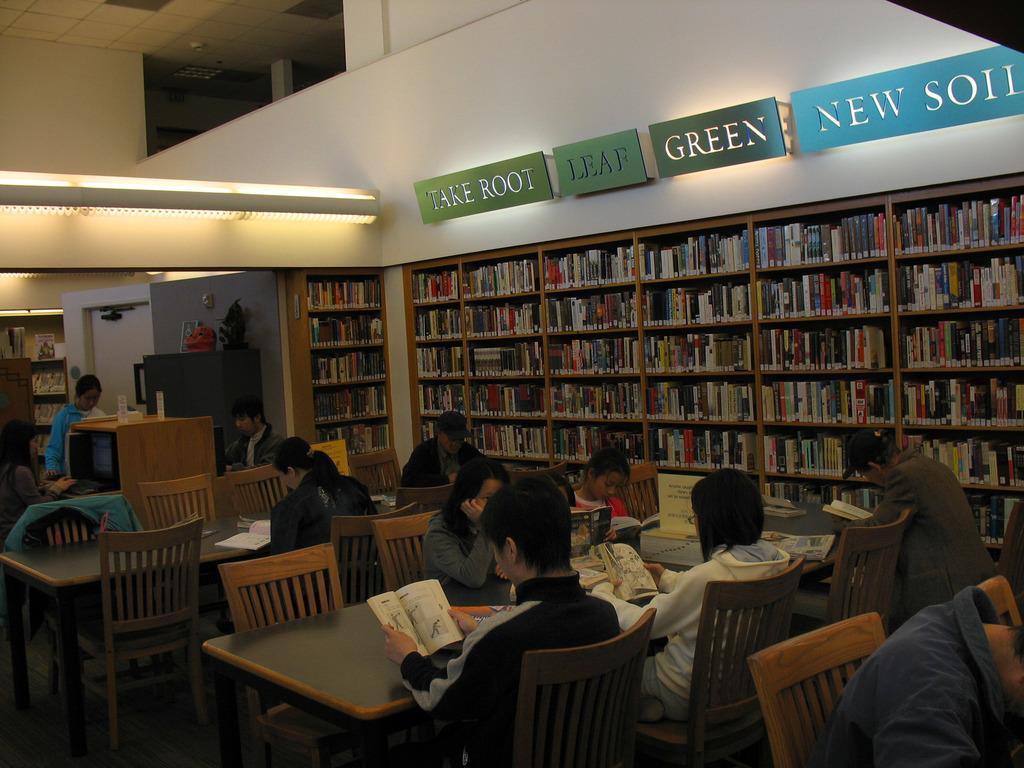In one or two sentences, can you explain what this image depicts? In this image there are group of people sitting in chair , and in the back ground there are name board , books in racks , table, chair ,plant,light. 